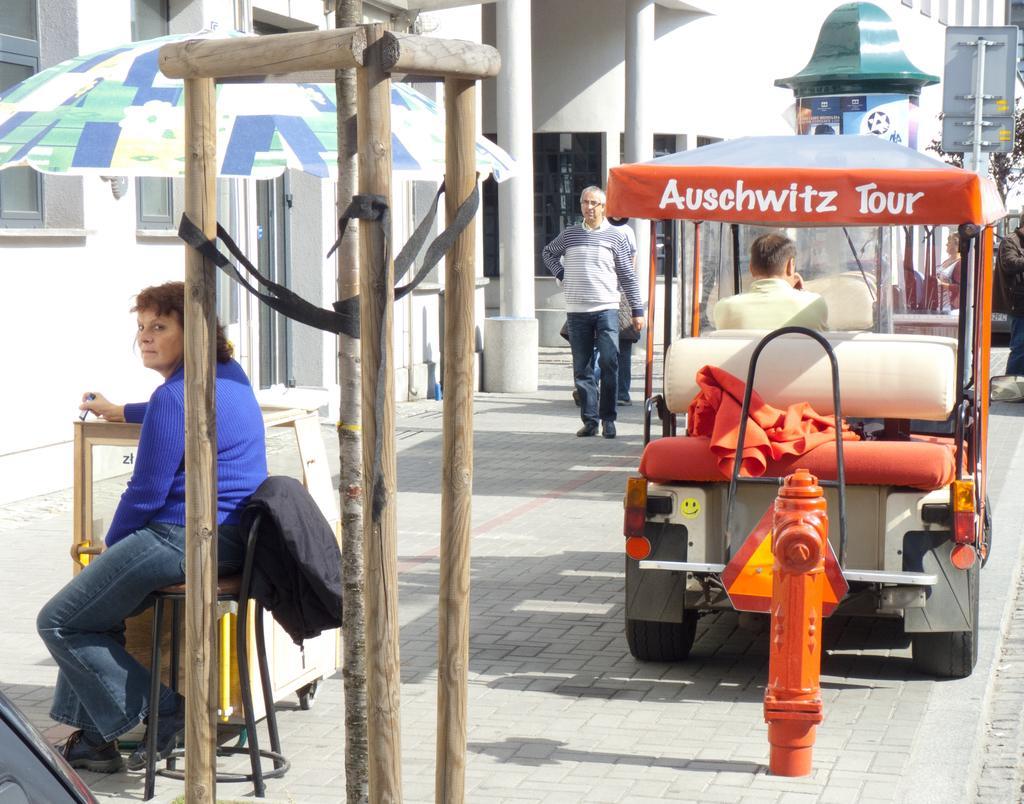Please provide a concise description of this image. In the center of the image we can see some people walking on the ground. On the left side of the image we can see some wooden poles a woman holding an object in her hand is sitting on a chair and a table placed on the ground, we can also see an umbrella. On the right side of the image we can see fire hose, one person sitting in a vehicle, sign boards and some people standing on the ground. At the top of the image we can see building with windows and pillars. 